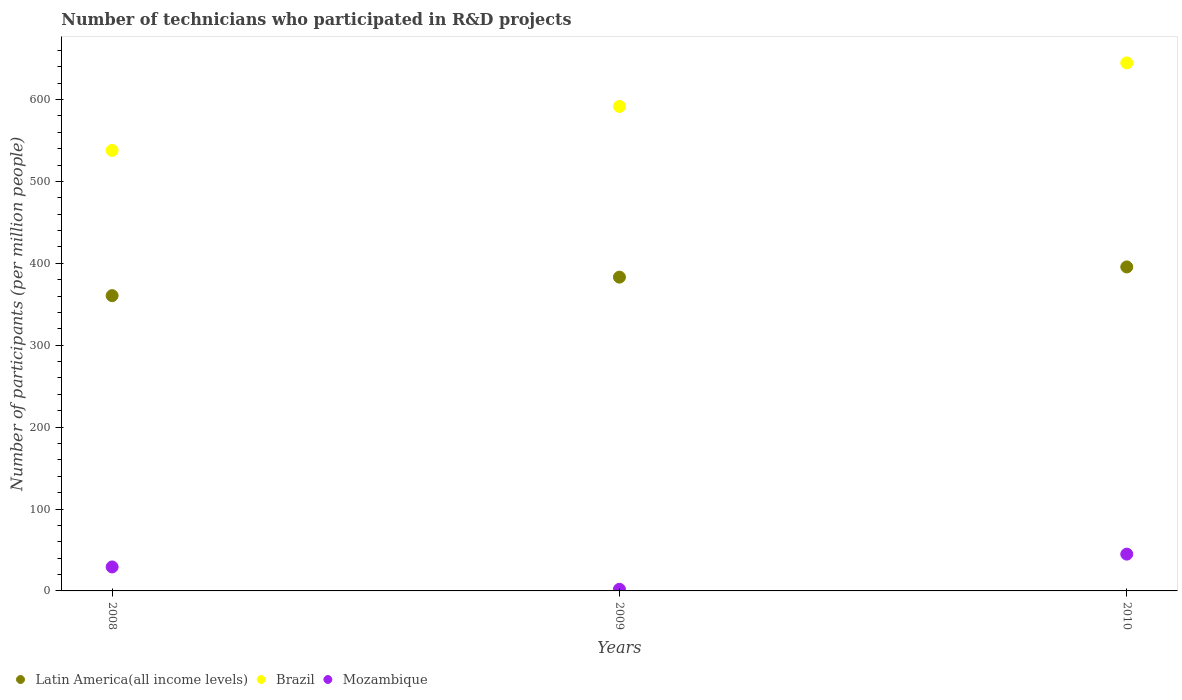How many different coloured dotlines are there?
Ensure brevity in your answer.  3. What is the number of technicians who participated in R&D projects in Latin America(all income levels) in 2008?
Offer a terse response. 360.57. Across all years, what is the maximum number of technicians who participated in R&D projects in Brazil?
Your answer should be compact. 644.75. Across all years, what is the minimum number of technicians who participated in R&D projects in Mozambique?
Offer a terse response. 2.01. In which year was the number of technicians who participated in R&D projects in Brazil maximum?
Provide a succinct answer. 2010. What is the total number of technicians who participated in R&D projects in Mozambique in the graph?
Your answer should be very brief. 76.22. What is the difference between the number of technicians who participated in R&D projects in Mozambique in 2009 and that in 2010?
Offer a terse response. -42.93. What is the difference between the number of technicians who participated in R&D projects in Mozambique in 2008 and the number of technicians who participated in R&D projects in Brazil in 2010?
Offer a very short reply. -615.47. What is the average number of technicians who participated in R&D projects in Latin America(all income levels) per year?
Your response must be concise. 379.77. In the year 2009, what is the difference between the number of technicians who participated in R&D projects in Brazil and number of technicians who participated in R&D projects in Mozambique?
Your answer should be very brief. 589.57. What is the ratio of the number of technicians who participated in R&D projects in Brazil in 2008 to that in 2009?
Give a very brief answer. 0.91. Is the number of technicians who participated in R&D projects in Latin America(all income levels) in 2008 less than that in 2009?
Provide a succinct answer. Yes. What is the difference between the highest and the second highest number of technicians who participated in R&D projects in Brazil?
Offer a very short reply. 53.18. What is the difference between the highest and the lowest number of technicians who participated in R&D projects in Latin America(all income levels)?
Keep it short and to the point. 35.03. In how many years, is the number of technicians who participated in R&D projects in Latin America(all income levels) greater than the average number of technicians who participated in R&D projects in Latin America(all income levels) taken over all years?
Your answer should be compact. 2. Does the number of technicians who participated in R&D projects in Mozambique monotonically increase over the years?
Your answer should be very brief. No. What is the difference between two consecutive major ticks on the Y-axis?
Offer a terse response. 100. Does the graph contain any zero values?
Offer a terse response. No. How are the legend labels stacked?
Your answer should be compact. Horizontal. What is the title of the graph?
Ensure brevity in your answer.  Number of technicians who participated in R&D projects. Does "Middle income" appear as one of the legend labels in the graph?
Provide a short and direct response. No. What is the label or title of the Y-axis?
Give a very brief answer. Number of participants (per million people). What is the Number of participants (per million people) in Latin America(all income levels) in 2008?
Your answer should be very brief. 360.57. What is the Number of participants (per million people) in Brazil in 2008?
Your response must be concise. 537.88. What is the Number of participants (per million people) in Mozambique in 2008?
Provide a succinct answer. 29.28. What is the Number of participants (per million people) in Latin America(all income levels) in 2009?
Offer a very short reply. 383.14. What is the Number of participants (per million people) of Brazil in 2009?
Offer a very short reply. 591.57. What is the Number of participants (per million people) of Mozambique in 2009?
Your response must be concise. 2.01. What is the Number of participants (per million people) of Latin America(all income levels) in 2010?
Provide a short and direct response. 395.59. What is the Number of participants (per million people) of Brazil in 2010?
Keep it short and to the point. 644.75. What is the Number of participants (per million people) of Mozambique in 2010?
Ensure brevity in your answer.  44.93. Across all years, what is the maximum Number of participants (per million people) of Latin America(all income levels)?
Your answer should be very brief. 395.59. Across all years, what is the maximum Number of participants (per million people) of Brazil?
Make the answer very short. 644.75. Across all years, what is the maximum Number of participants (per million people) of Mozambique?
Your answer should be compact. 44.93. Across all years, what is the minimum Number of participants (per million people) in Latin America(all income levels)?
Your answer should be very brief. 360.57. Across all years, what is the minimum Number of participants (per million people) in Brazil?
Ensure brevity in your answer.  537.88. Across all years, what is the minimum Number of participants (per million people) of Mozambique?
Offer a terse response. 2.01. What is the total Number of participants (per million people) of Latin America(all income levels) in the graph?
Offer a very short reply. 1139.3. What is the total Number of participants (per million people) in Brazil in the graph?
Ensure brevity in your answer.  1774.2. What is the total Number of participants (per million people) of Mozambique in the graph?
Your response must be concise. 76.22. What is the difference between the Number of participants (per million people) in Latin America(all income levels) in 2008 and that in 2009?
Offer a very short reply. -22.57. What is the difference between the Number of participants (per million people) in Brazil in 2008 and that in 2009?
Give a very brief answer. -53.69. What is the difference between the Number of participants (per million people) in Mozambique in 2008 and that in 2009?
Provide a short and direct response. 27.27. What is the difference between the Number of participants (per million people) in Latin America(all income levels) in 2008 and that in 2010?
Give a very brief answer. -35.03. What is the difference between the Number of participants (per million people) in Brazil in 2008 and that in 2010?
Offer a terse response. -106.87. What is the difference between the Number of participants (per million people) of Mozambique in 2008 and that in 2010?
Ensure brevity in your answer.  -15.66. What is the difference between the Number of participants (per million people) in Latin America(all income levels) in 2009 and that in 2010?
Give a very brief answer. -12.45. What is the difference between the Number of participants (per million people) of Brazil in 2009 and that in 2010?
Provide a succinct answer. -53.18. What is the difference between the Number of participants (per million people) of Mozambique in 2009 and that in 2010?
Keep it short and to the point. -42.93. What is the difference between the Number of participants (per million people) of Latin America(all income levels) in 2008 and the Number of participants (per million people) of Brazil in 2009?
Give a very brief answer. -231.01. What is the difference between the Number of participants (per million people) in Latin America(all income levels) in 2008 and the Number of participants (per million people) in Mozambique in 2009?
Make the answer very short. 358.56. What is the difference between the Number of participants (per million people) of Brazil in 2008 and the Number of participants (per million people) of Mozambique in 2009?
Your answer should be compact. 535.88. What is the difference between the Number of participants (per million people) of Latin America(all income levels) in 2008 and the Number of participants (per million people) of Brazil in 2010?
Offer a very short reply. -284.18. What is the difference between the Number of participants (per million people) in Latin America(all income levels) in 2008 and the Number of participants (per million people) in Mozambique in 2010?
Keep it short and to the point. 315.63. What is the difference between the Number of participants (per million people) in Brazil in 2008 and the Number of participants (per million people) in Mozambique in 2010?
Provide a succinct answer. 492.95. What is the difference between the Number of participants (per million people) of Latin America(all income levels) in 2009 and the Number of participants (per million people) of Brazil in 2010?
Provide a succinct answer. -261.61. What is the difference between the Number of participants (per million people) of Latin America(all income levels) in 2009 and the Number of participants (per million people) of Mozambique in 2010?
Offer a terse response. 338.21. What is the difference between the Number of participants (per million people) of Brazil in 2009 and the Number of participants (per million people) of Mozambique in 2010?
Ensure brevity in your answer.  546.64. What is the average Number of participants (per million people) of Latin America(all income levels) per year?
Keep it short and to the point. 379.77. What is the average Number of participants (per million people) in Brazil per year?
Provide a succinct answer. 591.4. What is the average Number of participants (per million people) of Mozambique per year?
Your answer should be very brief. 25.41. In the year 2008, what is the difference between the Number of participants (per million people) of Latin America(all income levels) and Number of participants (per million people) of Brazil?
Provide a succinct answer. -177.31. In the year 2008, what is the difference between the Number of participants (per million people) in Latin America(all income levels) and Number of participants (per million people) in Mozambique?
Offer a terse response. 331.29. In the year 2008, what is the difference between the Number of participants (per million people) of Brazil and Number of participants (per million people) of Mozambique?
Your answer should be compact. 508.61. In the year 2009, what is the difference between the Number of participants (per million people) of Latin America(all income levels) and Number of participants (per million people) of Brazil?
Your answer should be very brief. -208.43. In the year 2009, what is the difference between the Number of participants (per million people) of Latin America(all income levels) and Number of participants (per million people) of Mozambique?
Your answer should be compact. 381.14. In the year 2009, what is the difference between the Number of participants (per million people) in Brazil and Number of participants (per million people) in Mozambique?
Provide a short and direct response. 589.57. In the year 2010, what is the difference between the Number of participants (per million people) of Latin America(all income levels) and Number of participants (per million people) of Brazil?
Provide a succinct answer. -249.15. In the year 2010, what is the difference between the Number of participants (per million people) in Latin America(all income levels) and Number of participants (per million people) in Mozambique?
Ensure brevity in your answer.  350.66. In the year 2010, what is the difference between the Number of participants (per million people) of Brazil and Number of participants (per million people) of Mozambique?
Provide a succinct answer. 599.81. What is the ratio of the Number of participants (per million people) in Latin America(all income levels) in 2008 to that in 2009?
Keep it short and to the point. 0.94. What is the ratio of the Number of participants (per million people) of Brazil in 2008 to that in 2009?
Offer a very short reply. 0.91. What is the ratio of the Number of participants (per million people) in Mozambique in 2008 to that in 2009?
Offer a terse response. 14.59. What is the ratio of the Number of participants (per million people) in Latin America(all income levels) in 2008 to that in 2010?
Your answer should be compact. 0.91. What is the ratio of the Number of participants (per million people) of Brazil in 2008 to that in 2010?
Your answer should be very brief. 0.83. What is the ratio of the Number of participants (per million people) of Mozambique in 2008 to that in 2010?
Give a very brief answer. 0.65. What is the ratio of the Number of participants (per million people) in Latin America(all income levels) in 2009 to that in 2010?
Provide a short and direct response. 0.97. What is the ratio of the Number of participants (per million people) in Brazil in 2009 to that in 2010?
Your response must be concise. 0.92. What is the ratio of the Number of participants (per million people) of Mozambique in 2009 to that in 2010?
Make the answer very short. 0.04. What is the difference between the highest and the second highest Number of participants (per million people) of Latin America(all income levels)?
Your response must be concise. 12.45. What is the difference between the highest and the second highest Number of participants (per million people) in Brazil?
Your response must be concise. 53.18. What is the difference between the highest and the second highest Number of participants (per million people) in Mozambique?
Your response must be concise. 15.66. What is the difference between the highest and the lowest Number of participants (per million people) in Latin America(all income levels)?
Offer a very short reply. 35.03. What is the difference between the highest and the lowest Number of participants (per million people) in Brazil?
Your answer should be very brief. 106.87. What is the difference between the highest and the lowest Number of participants (per million people) in Mozambique?
Your answer should be very brief. 42.93. 